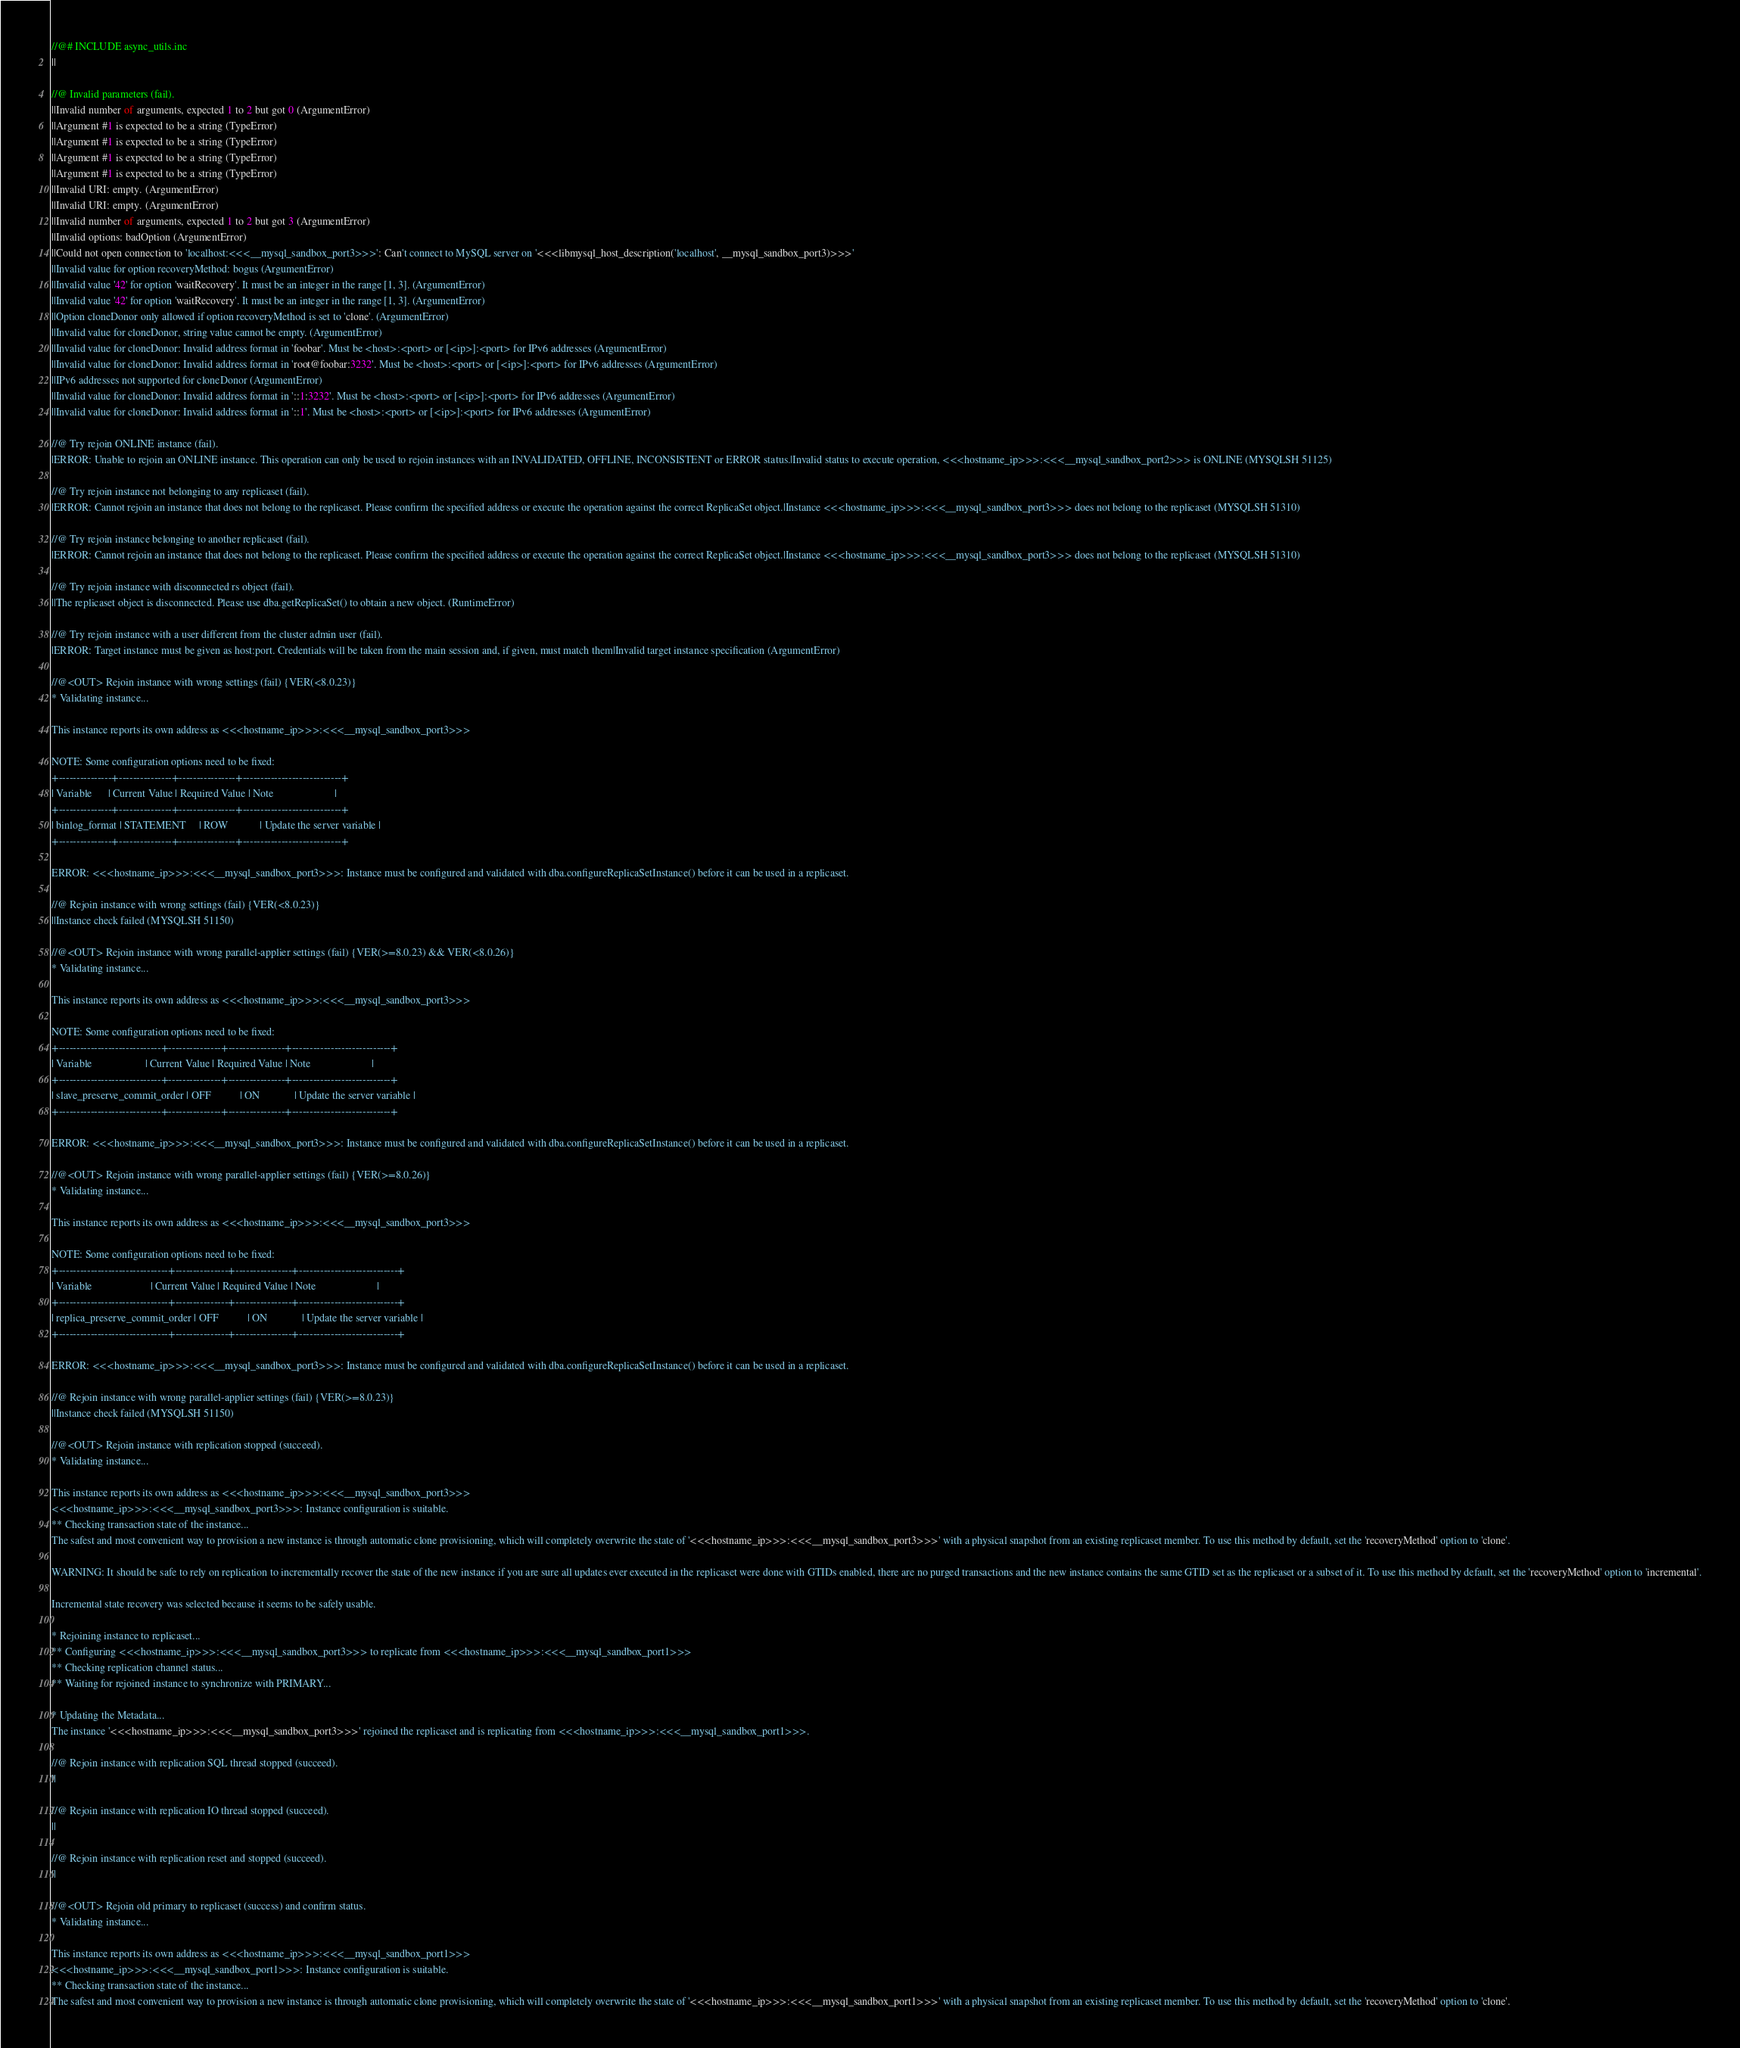Convert code to text. <code><loc_0><loc_0><loc_500><loc_500><_JavaScript_>//@# INCLUDE async_utils.inc
||

//@ Invalid parameters (fail).
||Invalid number of arguments, expected 1 to 2 but got 0 (ArgumentError)
||Argument #1 is expected to be a string (TypeError)
||Argument #1 is expected to be a string (TypeError)
||Argument #1 is expected to be a string (TypeError)
||Argument #1 is expected to be a string (TypeError)
||Invalid URI: empty. (ArgumentError)
||Invalid URI: empty. (ArgumentError)
||Invalid number of arguments, expected 1 to 2 but got 3 (ArgumentError)
||Invalid options: badOption (ArgumentError)
||Could not open connection to 'localhost:<<<__mysql_sandbox_port3>>>': Can't connect to MySQL server on '<<<libmysql_host_description('localhost', __mysql_sandbox_port3)>>>'
||Invalid value for option recoveryMethod: bogus (ArgumentError)
||Invalid value '42' for option 'waitRecovery'. It must be an integer in the range [1, 3]. (ArgumentError)
||Invalid value '42' for option 'waitRecovery'. It must be an integer in the range [1, 3]. (ArgumentError)
||Option cloneDonor only allowed if option recoveryMethod is set to 'clone'. (ArgumentError)
||Invalid value for cloneDonor, string value cannot be empty. (ArgumentError)
||Invalid value for cloneDonor: Invalid address format in 'foobar'. Must be <host>:<port> or [<ip>]:<port> for IPv6 addresses (ArgumentError)
||Invalid value for cloneDonor: Invalid address format in 'root@foobar:3232'. Must be <host>:<port> or [<ip>]:<port> for IPv6 addresses (ArgumentError)
||IPv6 addresses not supported for cloneDonor (ArgumentError)
||Invalid value for cloneDonor: Invalid address format in '::1:3232'. Must be <host>:<port> or [<ip>]:<port> for IPv6 addresses (ArgumentError)
||Invalid value for cloneDonor: Invalid address format in '::1'. Must be <host>:<port> or [<ip>]:<port> for IPv6 addresses (ArgumentError)

//@ Try rejoin ONLINE instance (fail).
|ERROR: Unable to rejoin an ONLINE instance. This operation can only be used to rejoin instances with an INVALIDATED, OFFLINE, INCONSISTENT or ERROR status.|Invalid status to execute operation, <<<hostname_ip>>>:<<<__mysql_sandbox_port2>>> is ONLINE (MYSQLSH 51125)

//@ Try rejoin instance not belonging to any replicaset (fail).
|ERROR: Cannot rejoin an instance that does not belong to the replicaset. Please confirm the specified address or execute the operation against the correct ReplicaSet object.|Instance <<<hostname_ip>>>:<<<__mysql_sandbox_port3>>> does not belong to the replicaset (MYSQLSH 51310)

//@ Try rejoin instance belonging to another replicaset (fail).
|ERROR: Cannot rejoin an instance that does not belong to the replicaset. Please confirm the specified address or execute the operation against the correct ReplicaSet object.|Instance <<<hostname_ip>>>:<<<__mysql_sandbox_port3>>> does not belong to the replicaset (MYSQLSH 51310)

//@ Try rejoin instance with disconnected rs object (fail).
||The replicaset object is disconnected. Please use dba.getReplicaSet() to obtain a new object. (RuntimeError)

//@ Try rejoin instance with a user different from the cluster admin user (fail).
|ERROR: Target instance must be given as host:port. Credentials will be taken from the main session and, if given, must match them|Invalid target instance specification (ArgumentError)

//@<OUT> Rejoin instance with wrong settings (fail) {VER(<8.0.23)}
* Validating instance...

This instance reports its own address as <<<hostname_ip>>>:<<<__mysql_sandbox_port3>>>

NOTE: Some configuration options need to be fixed:
+---------------+---------------+----------------+----------------------------+
| Variable      | Current Value | Required Value | Note                       |
+---------------+---------------+----------------+----------------------------+
| binlog_format | STATEMENT     | ROW            | Update the server variable |
+---------------+---------------+----------------+----------------------------+

ERROR: <<<hostname_ip>>>:<<<__mysql_sandbox_port3>>>: Instance must be configured and validated with dba.configureReplicaSetInstance() before it can be used in a replicaset.

//@ Rejoin instance with wrong settings (fail) {VER(<8.0.23)}
||Instance check failed (MYSQLSH 51150)

//@<OUT> Rejoin instance with wrong parallel-applier settings (fail) {VER(>=8.0.23) && VER(<8.0.26)}
* Validating instance...

This instance reports its own address as <<<hostname_ip>>>:<<<__mysql_sandbox_port3>>>

NOTE: Some configuration options need to be fixed:
+-----------------------------+---------------+----------------+----------------------------+
| Variable                    | Current Value | Required Value | Note                       |
+-----------------------------+---------------+----------------+----------------------------+
| slave_preserve_commit_order | OFF           | ON             | Update the server variable |
+-----------------------------+---------------+----------------+----------------------------+

ERROR: <<<hostname_ip>>>:<<<__mysql_sandbox_port3>>>: Instance must be configured and validated with dba.configureReplicaSetInstance() before it can be used in a replicaset.

//@<OUT> Rejoin instance with wrong parallel-applier settings (fail) {VER(>=8.0.26)}
* Validating instance...

This instance reports its own address as <<<hostname_ip>>>:<<<__mysql_sandbox_port3>>>

NOTE: Some configuration options need to be fixed:
+-------------------------------+---------------+----------------+----------------------------+
| Variable                      | Current Value | Required Value | Note                       |
+-------------------------------+---------------+----------------+----------------------------+
| replica_preserve_commit_order | OFF           | ON             | Update the server variable |
+-------------------------------+---------------+----------------+----------------------------+

ERROR: <<<hostname_ip>>>:<<<__mysql_sandbox_port3>>>: Instance must be configured and validated with dba.configureReplicaSetInstance() before it can be used in a replicaset.

//@ Rejoin instance with wrong parallel-applier settings (fail) {VER(>=8.0.23)}
||Instance check failed (MYSQLSH 51150)

//@<OUT> Rejoin instance with replication stopped (succeed).
* Validating instance...

This instance reports its own address as <<<hostname_ip>>>:<<<__mysql_sandbox_port3>>>
<<<hostname_ip>>>:<<<__mysql_sandbox_port3>>>: Instance configuration is suitable.
** Checking transaction state of the instance...
The safest and most convenient way to provision a new instance is through automatic clone provisioning, which will completely overwrite the state of '<<<hostname_ip>>>:<<<__mysql_sandbox_port3>>>' with a physical snapshot from an existing replicaset member. To use this method by default, set the 'recoveryMethod' option to 'clone'.

WARNING: It should be safe to rely on replication to incrementally recover the state of the new instance if you are sure all updates ever executed in the replicaset were done with GTIDs enabled, there are no purged transactions and the new instance contains the same GTID set as the replicaset or a subset of it. To use this method by default, set the 'recoveryMethod' option to 'incremental'.

Incremental state recovery was selected because it seems to be safely usable.

* Rejoining instance to replicaset...
** Configuring <<<hostname_ip>>>:<<<__mysql_sandbox_port3>>> to replicate from <<<hostname_ip>>>:<<<__mysql_sandbox_port1>>>
** Checking replication channel status...
** Waiting for rejoined instance to synchronize with PRIMARY...

* Updating the Metadata...
The instance '<<<hostname_ip>>>:<<<__mysql_sandbox_port3>>>' rejoined the replicaset and is replicating from <<<hostname_ip>>>:<<<__mysql_sandbox_port1>>>.

//@ Rejoin instance with replication SQL thread stopped (succeed).
||

//@ Rejoin instance with replication IO thread stopped (succeed).
||

//@ Rejoin instance with replication reset and stopped (succeed).
||

//@<OUT> Rejoin old primary to replicaset (success) and confirm status.
* Validating instance...

This instance reports its own address as <<<hostname_ip>>>:<<<__mysql_sandbox_port1>>>
<<<hostname_ip>>>:<<<__mysql_sandbox_port1>>>: Instance configuration is suitable.
** Checking transaction state of the instance...
The safest and most convenient way to provision a new instance is through automatic clone provisioning, which will completely overwrite the state of '<<<hostname_ip>>>:<<<__mysql_sandbox_port1>>>' with a physical snapshot from an existing replicaset member. To use this method by default, set the 'recoveryMethod' option to 'clone'.
</code> 